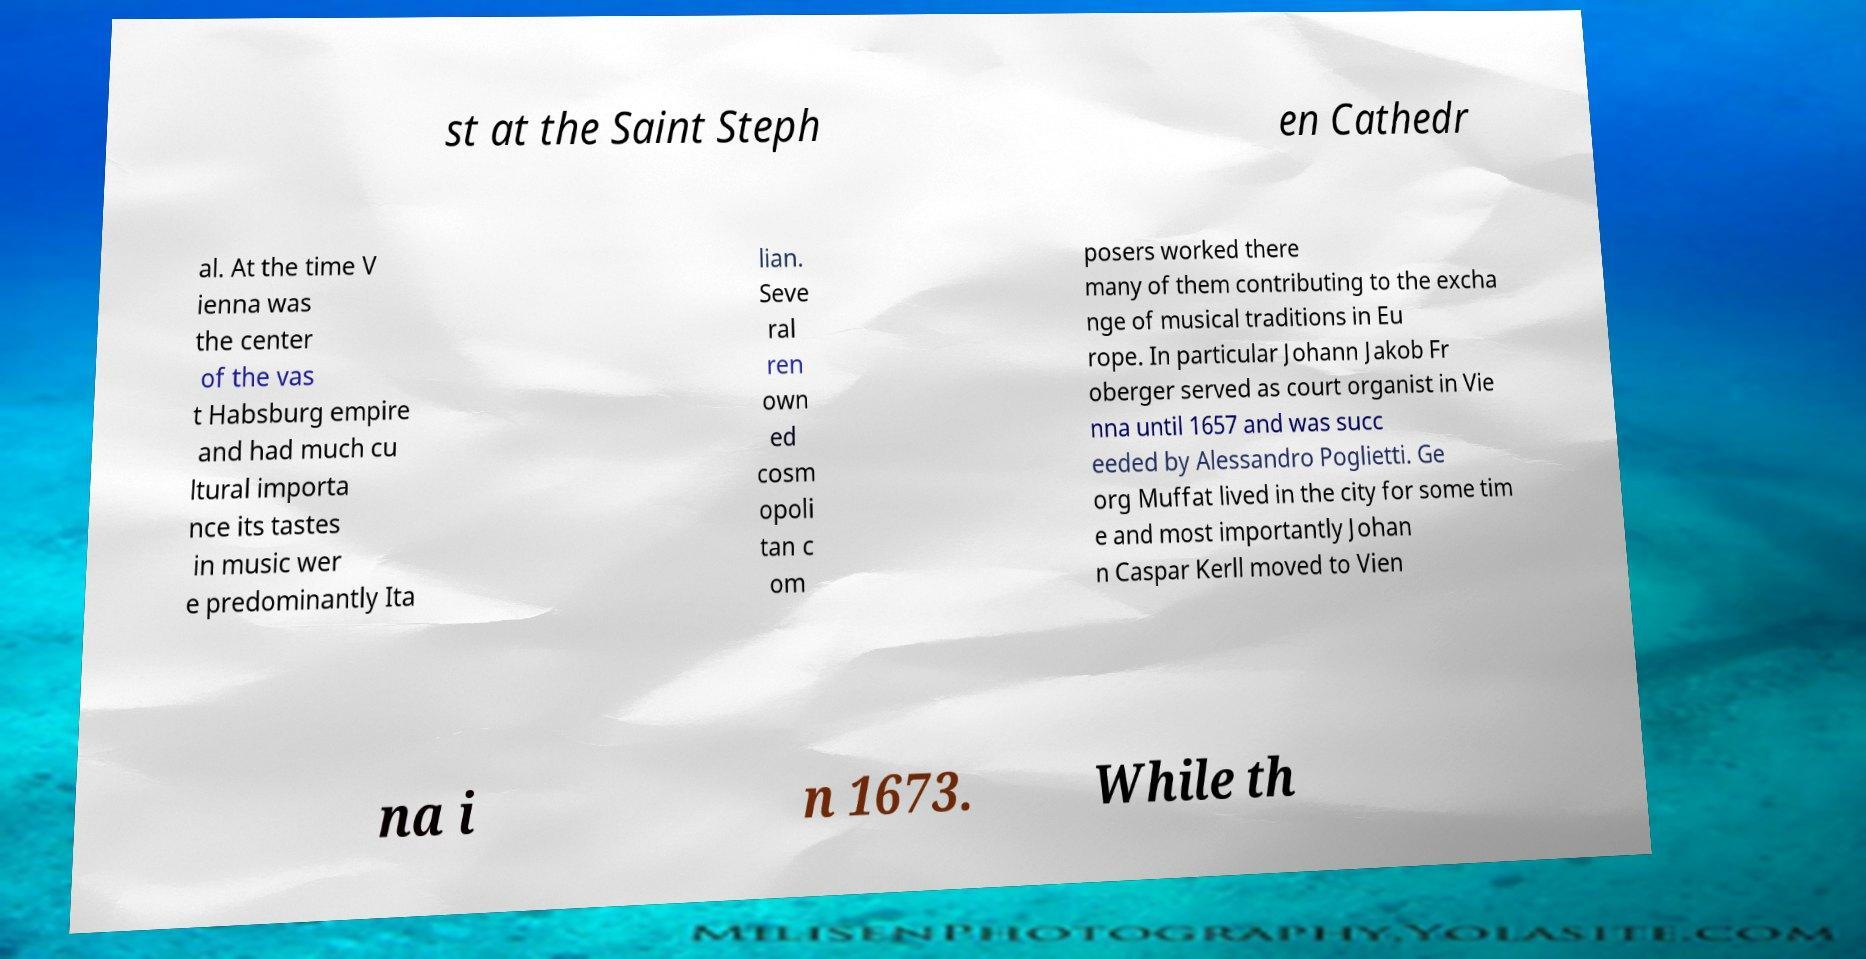There's text embedded in this image that I need extracted. Can you transcribe it verbatim? st at the Saint Steph en Cathedr al. At the time V ienna was the center of the vas t Habsburg empire and had much cu ltural importa nce its tastes in music wer e predominantly Ita lian. Seve ral ren own ed cosm opoli tan c om posers worked there many of them contributing to the excha nge of musical traditions in Eu rope. In particular Johann Jakob Fr oberger served as court organist in Vie nna until 1657 and was succ eeded by Alessandro Poglietti. Ge org Muffat lived in the city for some tim e and most importantly Johan n Caspar Kerll moved to Vien na i n 1673. While th 